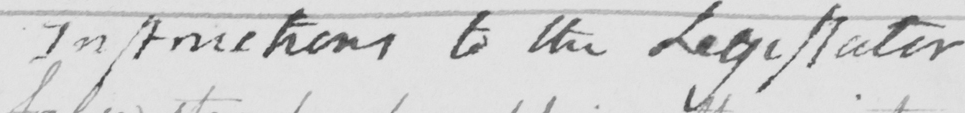What does this handwritten line say? Instructions to the Legislator 